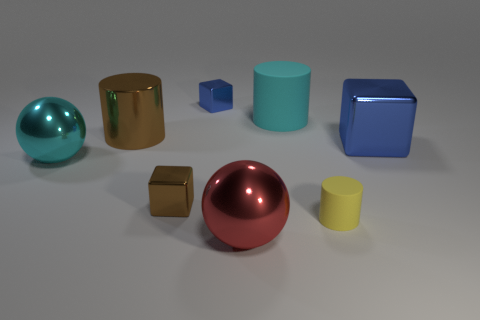What number of blue things are big spheres or cylinders?
Your answer should be very brief. 0. Is there a large shiny ball behind the large metal sphere that is in front of the shiny ball to the left of the brown metal cylinder?
Offer a very short reply. Yes. Is there any other thing that is the same size as the brown block?
Your answer should be compact. Yes. Is the big matte cylinder the same color as the shiny cylinder?
Your answer should be very brief. No. There is a tiny metal object behind the metal ball that is on the left side of the brown cube; what is its color?
Give a very brief answer. Blue. How many large objects are cyan rubber objects or purple rubber spheres?
Your answer should be compact. 1. The cylinder that is behind the brown metal block and right of the brown cylinder is what color?
Provide a short and direct response. Cyan. Does the big red sphere have the same material as the brown cylinder?
Give a very brief answer. Yes. What shape is the small blue thing?
Provide a short and direct response. Cube. There is a cyan object behind the brown metallic object behind the small brown metallic block; how many blue metal objects are left of it?
Offer a very short reply. 1. 